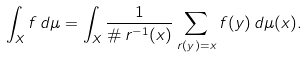Convert formula to latex. <formula><loc_0><loc_0><loc_500><loc_500>\int _ { X } f \, d \mu = \int _ { X } \frac { 1 } { \# \, r ^ { - 1 } ( x ) } \sum _ { r ( y ) = x } f ( y ) \, d \mu ( x ) .</formula> 